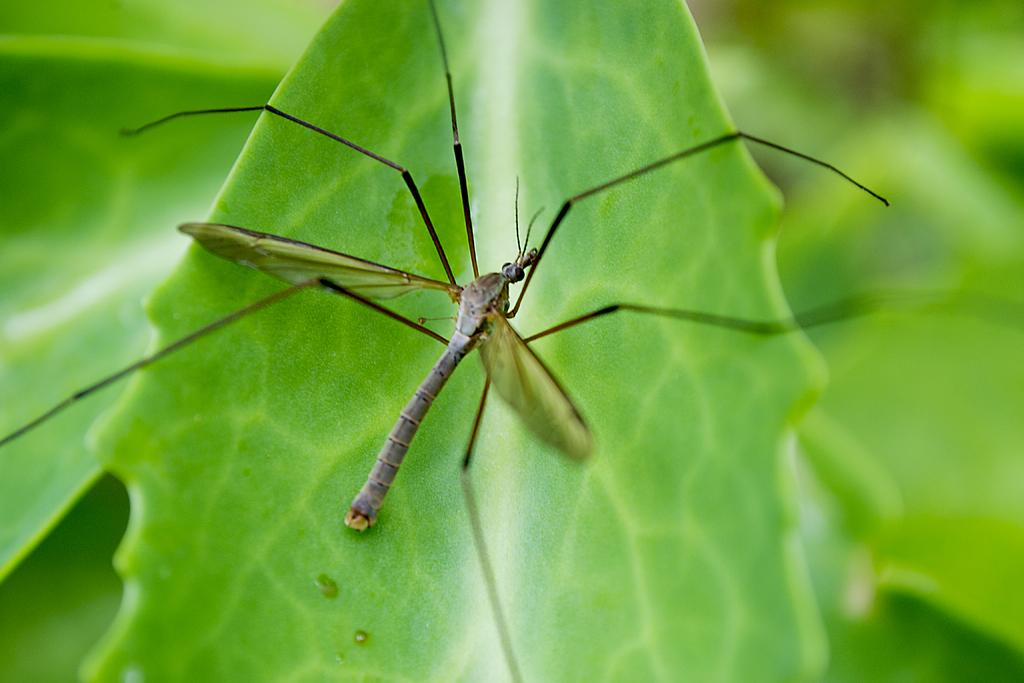What is present in the image? There is a fly in the image. Where is the fly located? The fly is on a leaf. What type of horn can be seen on the fly in the image? There is no horn present on the fly in the image. 